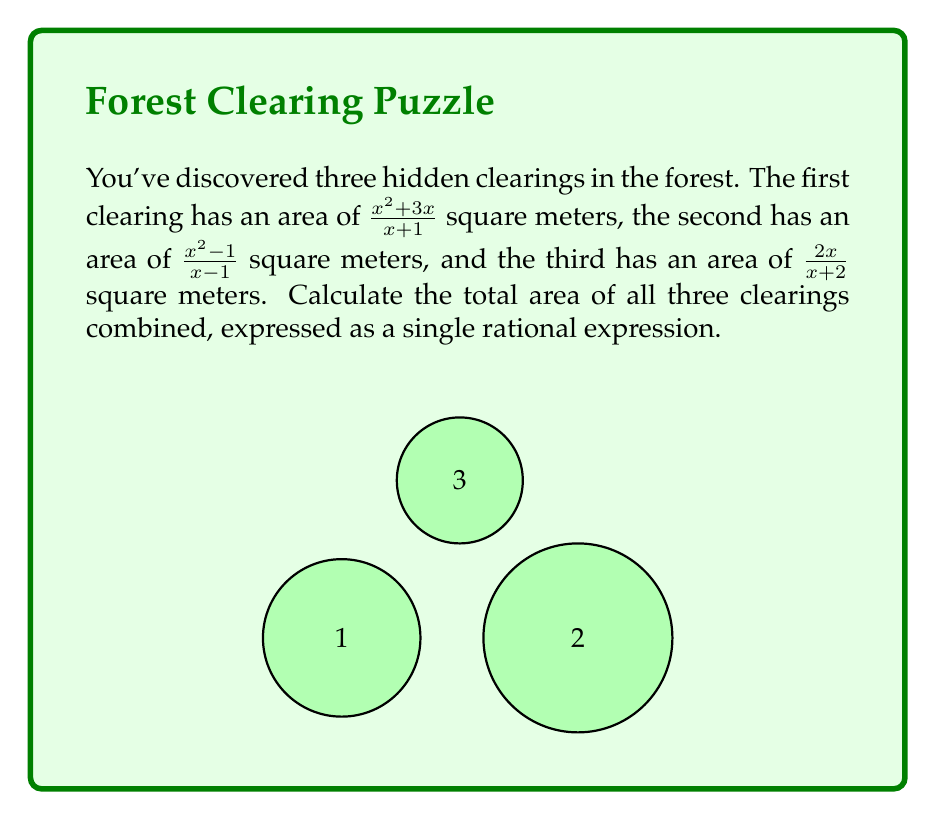What is the answer to this math problem? To find the total area, we need to add the three rational expressions:

$$\frac{x^2+3x}{x+1} + \frac{x^2-1}{x-1} + \frac{2x}{x+2}$$

1) First, let's find a common denominator. The LCD is $(x+1)(x-1)(x+2)$.

2) Multiply each fraction by the appropriate factor to get the common denominator:

   $$\frac{x^2+3x}{x+1} \cdot \frac{(x-1)(x+2)}{(x-1)(x+2)} + \frac{x^2-1}{x-1} \cdot \frac{(x+1)(x+2)}{(x+1)(x+2)} + \frac{2x}{x+2} \cdot \frac{(x+1)(x-1)}{(x+1)(x-1)}$$

3) Simplify the numerators:

   $$\frac{(x^2+3x)(x-1)(x+2)}{(x+1)(x-1)(x+2)} + \frac{(x^2-1)(x+1)(x+2)}{(x+1)(x-1)(x+2)} + \frac{2x(x+1)(x-1)}{(x+1)(x-1)(x+2)}$$

4) Expand the numerators:

   $$\frac{x^3+2x^2-x^2-3x^2+x-3x}{(x+1)(x-1)(x+2)} + \frac{x^3+2x^2-x-2}{(x+1)(x-1)(x+2)} + \frac{2x^2+2x-2x^2+2x}{(x+1)(x-1)(x+2)}$$

5) Simplify the numerators:

   $$\frac{x^3-2x^2-2x}{(x+1)(x-1)(x+2)} + \frac{x^3+2x^2-x-2}{(x+1)(x-1)(x+2)} + \frac{4x}{(x+1)(x-1)(x+2)}$$

6) Add the numerators:

   $$\frac{x^3-2x^2-2x + x^3+2x^2-x-2 + 4x}{(x+1)(x-1)(x+2)}$$

7) Simplify the numerator:

   $$\frac{2x^3+x-2}{(x+1)(x-1)(x+2)}$$

This is the simplified rational expression for the total area of the three clearings.
Answer: $\frac{2x^3+x-2}{(x+1)(x-1)(x+2)}$ square meters 